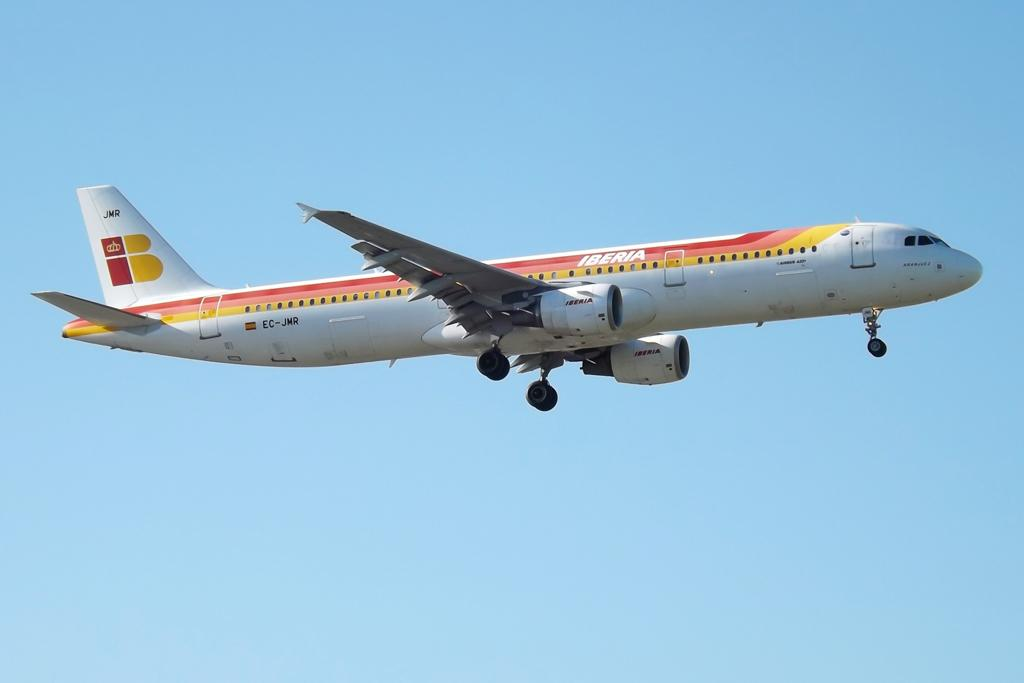<image>
Write a terse but informative summary of the picture. The Iberia Air plane is white with a red with pink, yellow, and red stripes. 